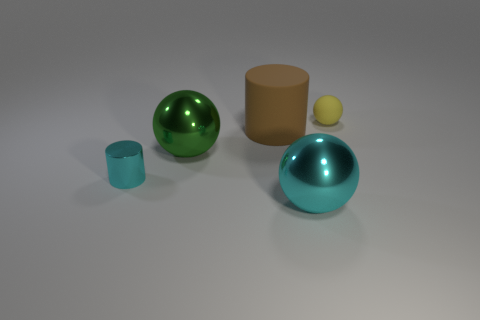There is a large object that is the same color as the small metallic cylinder; what material is it?
Offer a terse response. Metal. Does the cyan metal thing left of the cyan metallic sphere have the same shape as the matte thing that is to the left of the small matte thing?
Your answer should be compact. Yes. What number of other objects are the same size as the yellow rubber ball?
Make the answer very short. 1. How big is the cyan metallic sphere?
Ensure brevity in your answer.  Large. Does the thing behind the brown object have the same material as the large brown thing?
Ensure brevity in your answer.  Yes. What color is the other big thing that is the same shape as the big green metal thing?
Your response must be concise. Cyan. There is a cylinder to the left of the big green object; is its color the same as the small rubber object?
Provide a short and direct response. No. Are there any big brown objects on the left side of the cyan metal cylinder?
Give a very brief answer. No. What color is the big object that is behind the small cyan object and on the right side of the green sphere?
Keep it short and to the point. Brown. The shiny thing that is the same color as the metal cylinder is what shape?
Offer a terse response. Sphere. 